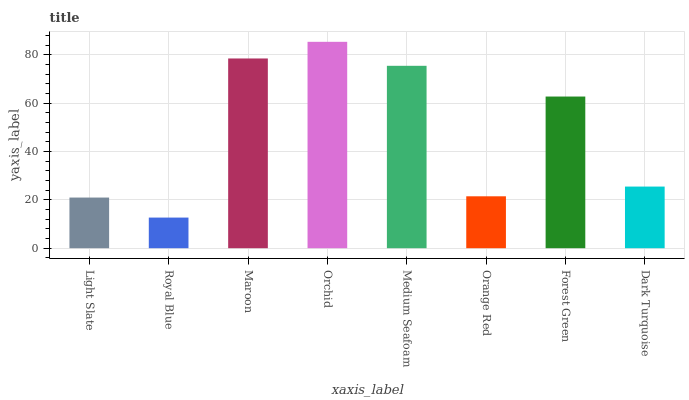Is Royal Blue the minimum?
Answer yes or no. Yes. Is Orchid the maximum?
Answer yes or no. Yes. Is Maroon the minimum?
Answer yes or no. No. Is Maroon the maximum?
Answer yes or no. No. Is Maroon greater than Royal Blue?
Answer yes or no. Yes. Is Royal Blue less than Maroon?
Answer yes or no. Yes. Is Royal Blue greater than Maroon?
Answer yes or no. No. Is Maroon less than Royal Blue?
Answer yes or no. No. Is Forest Green the high median?
Answer yes or no. Yes. Is Dark Turquoise the low median?
Answer yes or no. Yes. Is Medium Seafoam the high median?
Answer yes or no. No. Is Orange Red the low median?
Answer yes or no. No. 